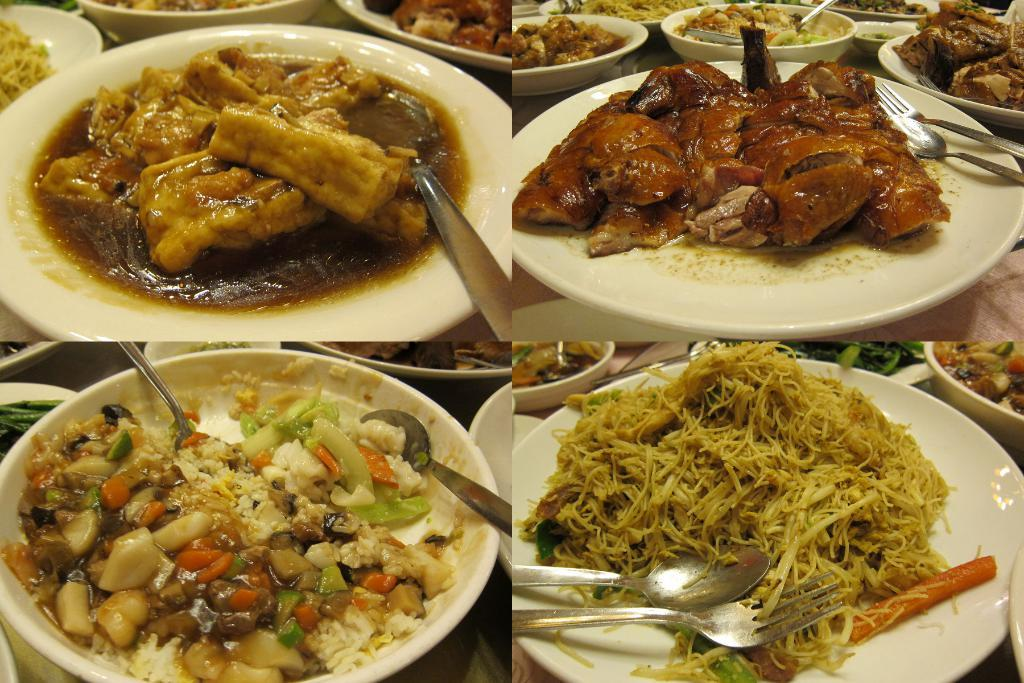What is the main subject of the image? The image contains a collage of four pictures. What can be seen in the pictures? There are plates and bowls in the pictures, and there is food in the plates and bowls. What utensils are visible in the pictures? Spoons and forks are visible in the pictures. Are there any rings visible in the image? There are no rings present in the image. What type of punishment is being depicted in the image? There is no punishment being depicted in the image; it features a collage of pictures with plates, bowls, food, and utensils. 